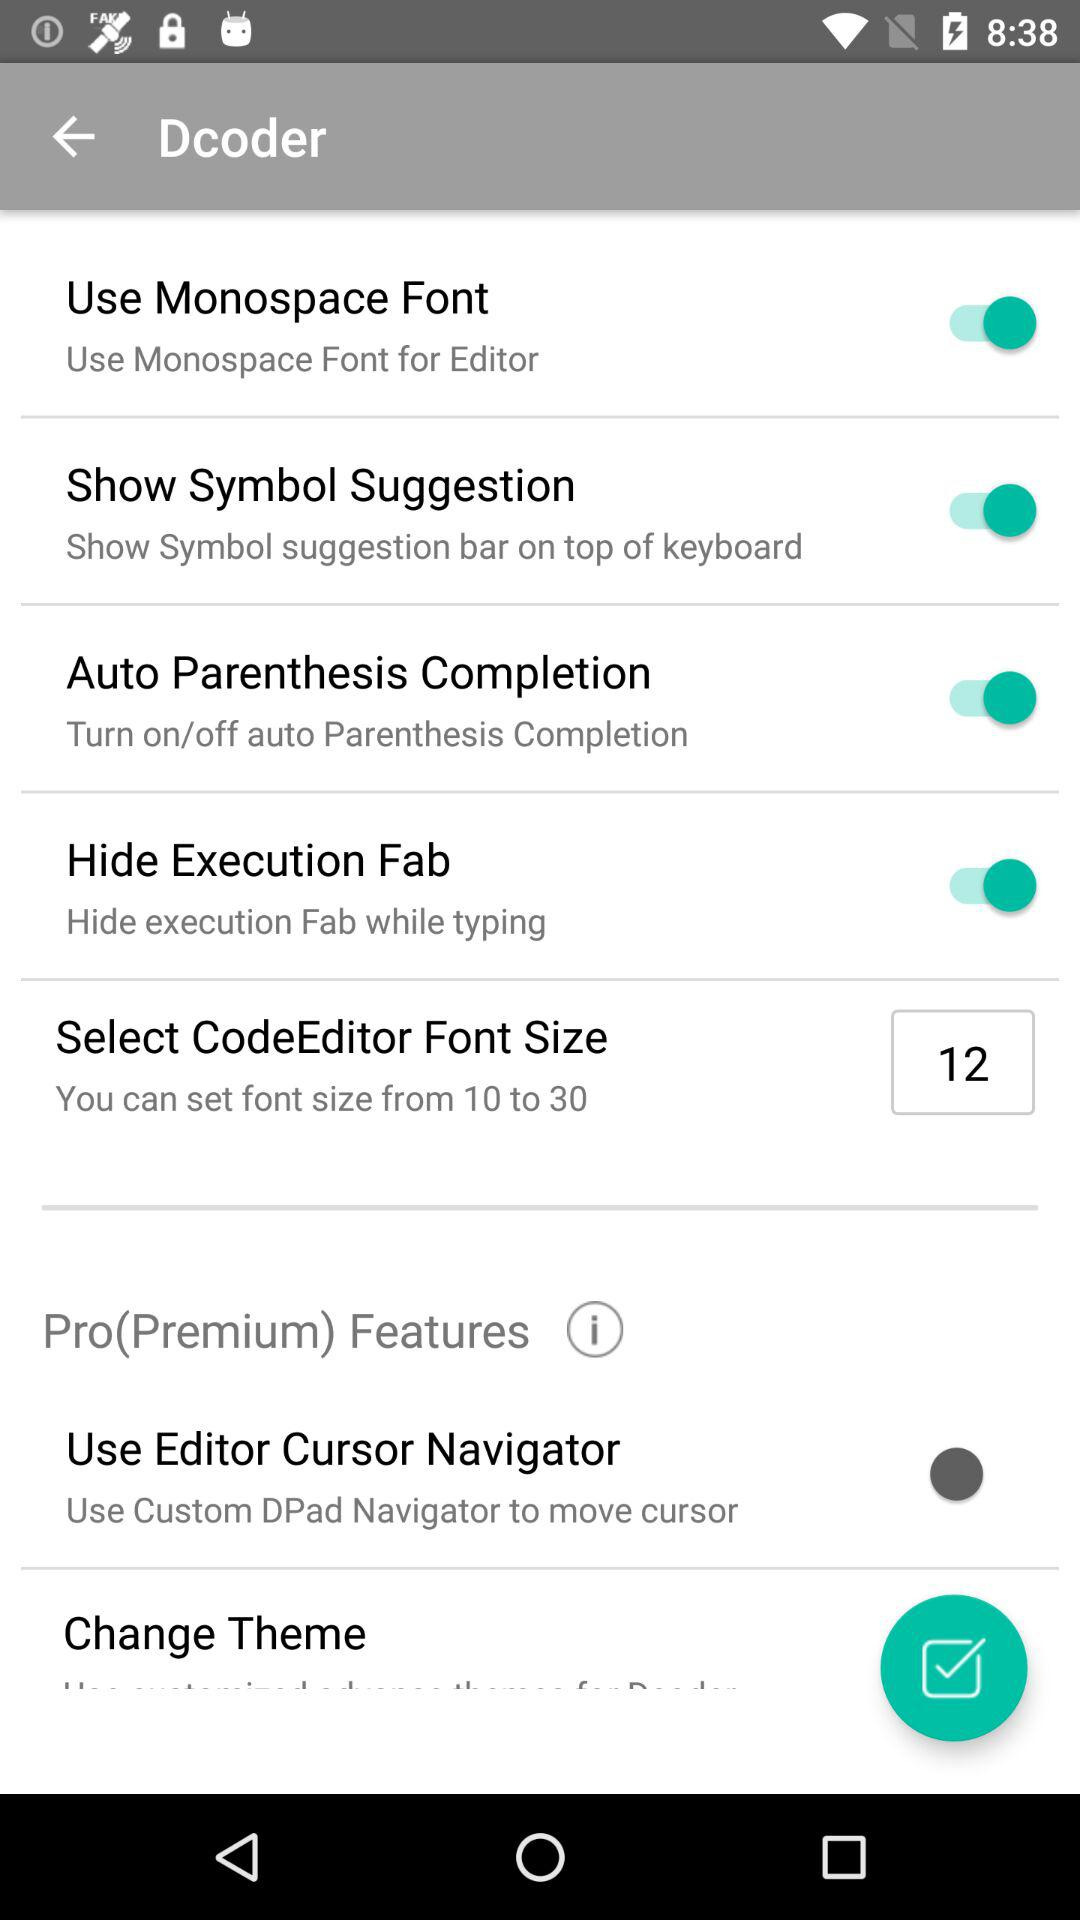How many items are there in the editor settings that have a switch?
Answer the question using a single word or phrase. 4 